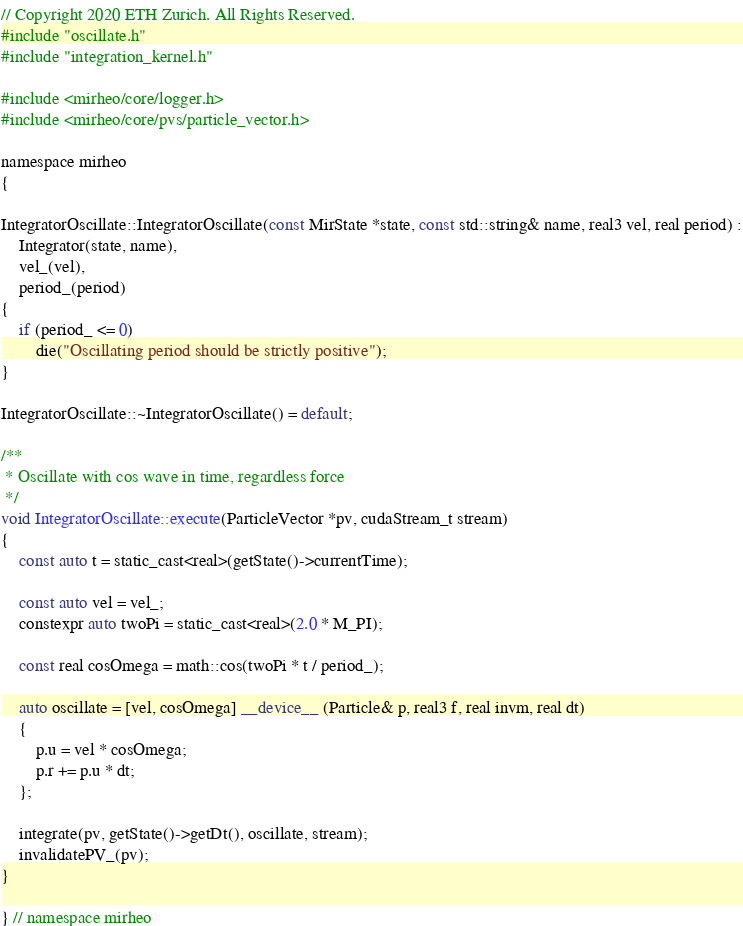Convert code to text. <code><loc_0><loc_0><loc_500><loc_500><_Cuda_>// Copyright 2020 ETH Zurich. All Rights Reserved.
#include "oscillate.h"
#include "integration_kernel.h"

#include <mirheo/core/logger.h>
#include <mirheo/core/pvs/particle_vector.h>

namespace mirheo
{

IntegratorOscillate::IntegratorOscillate(const MirState *state, const std::string& name, real3 vel, real period) :
    Integrator(state, name),
    vel_(vel),
    period_(period)
{
    if (period_ <= 0)
        die("Oscillating period should be strictly positive");
}

IntegratorOscillate::~IntegratorOscillate() = default;

/**
 * Oscillate with cos wave in time, regardless force
 */
void IntegratorOscillate::execute(ParticleVector *pv, cudaStream_t stream)
{
    const auto t = static_cast<real>(getState()->currentTime);

    const auto vel = vel_;
    constexpr auto twoPi = static_cast<real>(2.0 * M_PI);

    const real cosOmega = math::cos(twoPi * t / period_);

    auto oscillate = [vel, cosOmega] __device__ (Particle& p, real3 f, real invm, real dt)
    {
        p.u = vel * cosOmega;
        p.r += p.u * dt;
    };

    integrate(pv, getState()->getDt(), oscillate, stream);
    invalidatePV_(pv);
}

} // namespace mirheo
</code> 